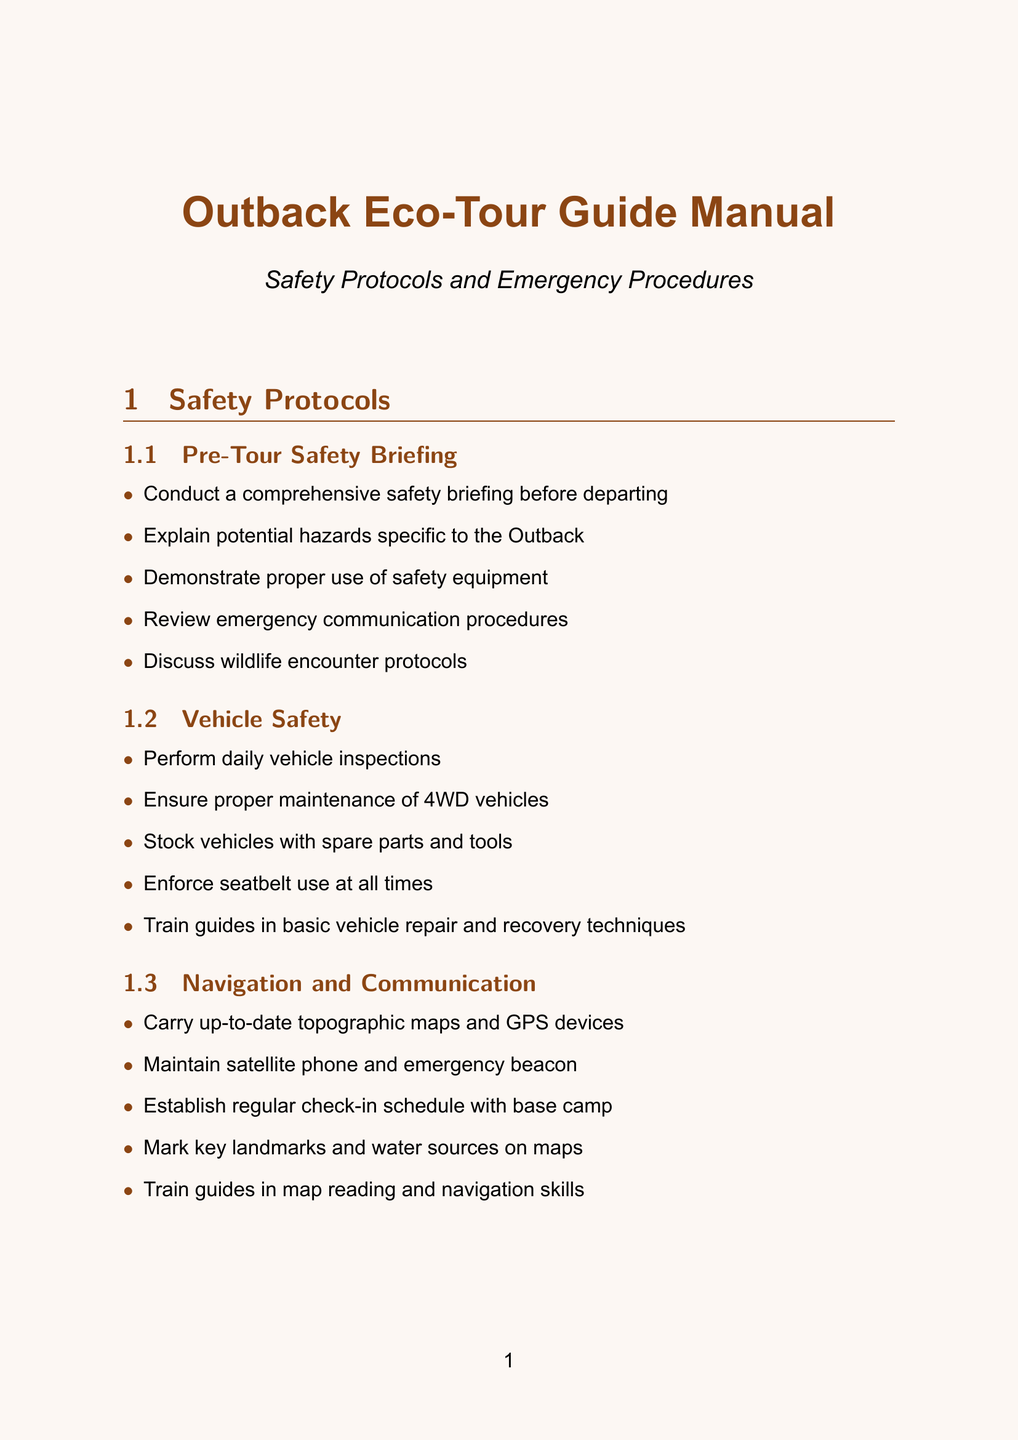What is the first step of the Pre-Tour Safety Briefing? The first step outlined is to conduct a comprehensive safety briefing before departing.
Answer: Conduct a comprehensive safety briefing How many items are in the Vehicle Safety section? The Vehicle Safety section contains five specific items listed.
Answer: 5 What should guides be trained in for Medical Emergencies? Guides should be trained in wilderness first aid and CPR as part of the emergency procedures for medical situations.
Answer: Wilderness first aid and CPR What are participants equipped with in the Lost Person Procedure? Participants are equipped with whistles and emergency blankets to assist in the lost person procedure.
Answer: Whistles and emergency blankets What principle should guides follow to minimize environmental impact? Guides should follow the 'Leave No Trace' principles as stated in the environmental considerations.
Answer: Leave No Trace What is the primary focus of the Severe Weather Response section? The primary focus is on monitoring weather forecasts regularly and responding appropriately to severe weather conditions.
Answer: Monitoring weather forecasts How should activities be scheduled in regard to heat management? Activities should be scheduled during cooler parts of the day to manage heat and dehydration effectively.
Answer: Cooler parts of the day What type of safety equipment must be demonstrated? Proper use of safety equipment must be demonstrated during the Pre-Tour Safety Briefing.
Answer: Safety equipment What should be maintained for medical emergencies? A well-stocked first aid kit should be maintained for medical emergencies.
Answer: First aid kits 